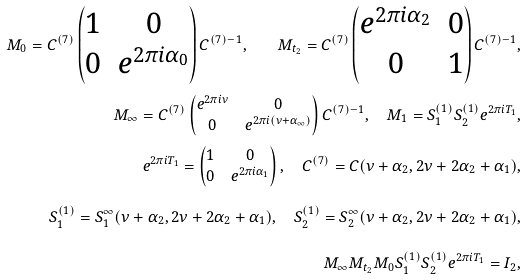<formula> <loc_0><loc_0><loc_500><loc_500>M _ { 0 } = C ^ { ( 7 ) } \left ( \begin{matrix} 1 & 0 \\ 0 & e ^ { 2 \pi i \alpha _ { 0 } } \end{matrix} \right ) C ^ { ( 7 ) - 1 } , \quad M _ { t _ { 2 } } = C ^ { ( 7 ) } \left ( \begin{matrix} e ^ { 2 \pi i \alpha _ { 2 } } & 0 \\ 0 & 1 \end{matrix} \right ) C ^ { ( 7 ) - 1 } , \\ M _ { \infty } = C ^ { ( 7 ) } \left ( \begin{matrix} e ^ { 2 \pi i \nu } & 0 \\ 0 & e ^ { 2 \pi i ( \nu + \alpha _ { \infty } ) } \end{matrix} \right ) C ^ { ( 7 ) - 1 } , \quad M _ { 1 } = S _ { 1 } ^ { ( 1 ) } S _ { 2 } ^ { ( 1 ) } e ^ { 2 \pi i T _ { 1 } } , \\ e ^ { 2 \pi i T _ { 1 } } = \left ( \begin{matrix} 1 & 0 \\ 0 & e ^ { 2 \pi i \alpha _ { 1 } } \end{matrix} \right ) , \quad C ^ { ( 7 ) } = C ( \nu + \alpha _ { 2 } , 2 \nu + 2 \alpha _ { 2 } + \alpha _ { 1 } ) , \\ S _ { 1 } ^ { ( 1 ) } = S _ { 1 } ^ { \infty } ( \nu + \alpha _ { 2 } , 2 \nu + 2 \alpha _ { 2 } + \alpha _ { 1 } ) , \quad S _ { 2 } ^ { ( 1 ) } = S _ { 2 } ^ { \infty } ( \nu + \alpha _ { 2 } , 2 \nu + 2 \alpha _ { 2 } + \alpha _ { 1 } ) , \\ M _ { \infty } M _ { t _ { 2 } } M _ { 0 } S _ { 1 } ^ { ( 1 ) } S _ { 2 } ^ { ( 1 ) } e ^ { 2 \pi i T _ { 1 } } = I _ { 2 } ,</formula> 